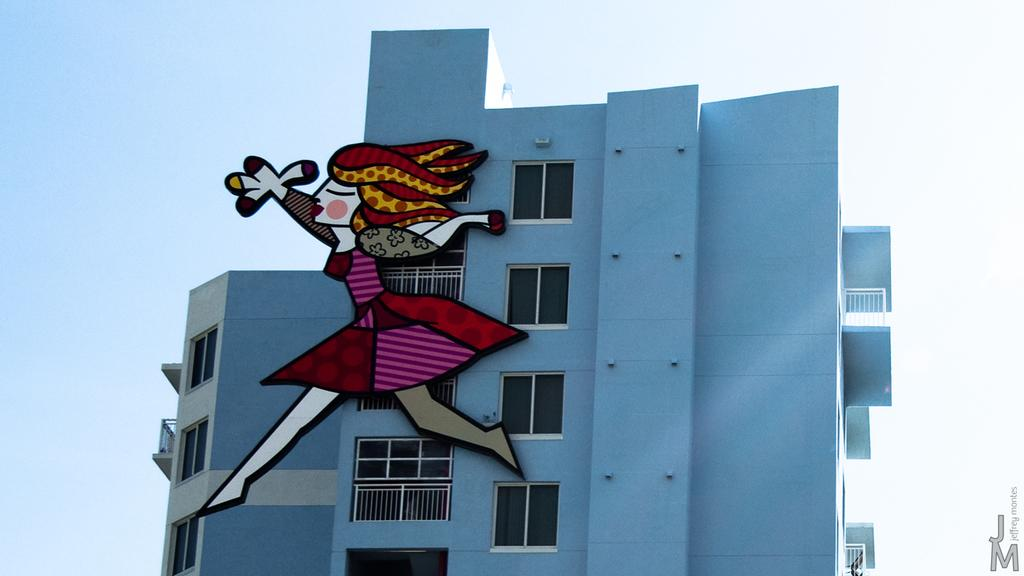What is the color of the building in the image? The building in the image is blue. What feature of the building is mentioned in the facts? The building has multiple windows. What type of character can be seen in the image? A cartoon character is visible in the image. What can be seen in the background of the image? The sky is visible in the background of the image. Are there any farms visible in the image? No, there are no farms present in the image. Can you see a tramp in the image? No, there is no tramp present in the image. 